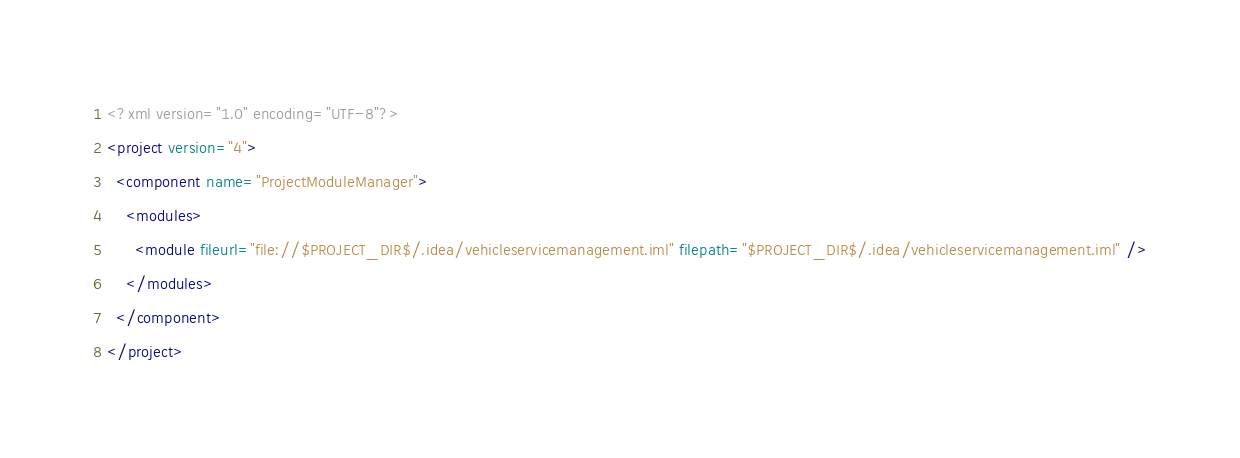<code> <loc_0><loc_0><loc_500><loc_500><_XML_><?xml version="1.0" encoding="UTF-8"?>
<project version="4">
  <component name="ProjectModuleManager">
    <modules>
      <module fileurl="file://$PROJECT_DIR$/.idea/vehicleservicemanagement.iml" filepath="$PROJECT_DIR$/.idea/vehicleservicemanagement.iml" />
    </modules>
  </component>
</project></code> 